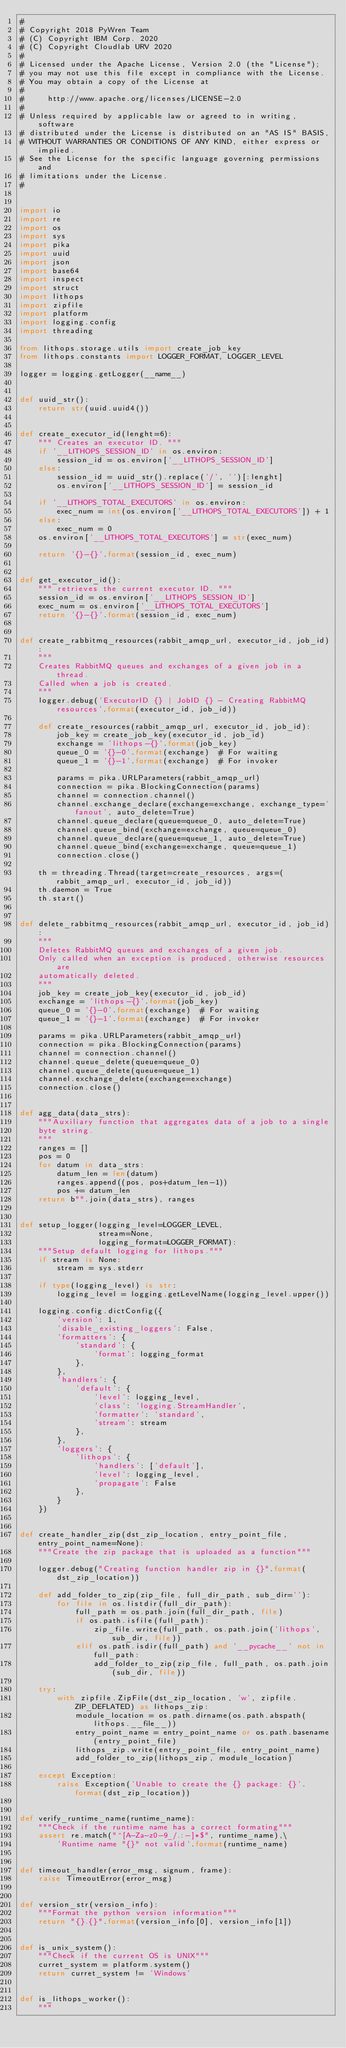<code> <loc_0><loc_0><loc_500><loc_500><_Python_>#
# Copyright 2018 PyWren Team
# (C) Copyright IBM Corp. 2020
# (C) Copyright Cloudlab URV 2020
#
# Licensed under the Apache License, Version 2.0 (the "License");
# you may not use this file except in compliance with the License.
# You may obtain a copy of the License at
#
#     http://www.apache.org/licenses/LICENSE-2.0
#
# Unless required by applicable law or agreed to in writing, software
# distributed under the License is distributed on an "AS IS" BASIS,
# WITHOUT WARRANTIES OR CONDITIONS OF ANY KIND, either express or implied.
# See the License for the specific language governing permissions and
# limitations under the License.
#


import io
import re
import os
import sys
import pika
import uuid
import json
import base64
import inspect
import struct
import lithops
import zipfile
import platform
import logging.config
import threading

from lithops.storage.utils import create_job_key
from lithops.constants import LOGGER_FORMAT, LOGGER_LEVEL

logger = logging.getLogger(__name__)


def uuid_str():
    return str(uuid.uuid4())


def create_executor_id(lenght=6):
    """ Creates an executor ID. """
    if '__LITHOPS_SESSION_ID' in os.environ:
        session_id = os.environ['__LITHOPS_SESSION_ID']
    else:
        session_id = uuid_str().replace('/', '')[:lenght]
        os.environ['__LITHOPS_SESSION_ID'] = session_id

    if '__LITHOPS_TOTAL_EXECUTORS' in os.environ:
        exec_num = int(os.environ['__LITHOPS_TOTAL_EXECUTORS']) + 1
    else:
        exec_num = 0
    os.environ['__LITHOPS_TOTAL_EXECUTORS'] = str(exec_num)

    return '{}-{}'.format(session_id, exec_num)


def get_executor_id():
    """ retrieves the current executor ID. """
    session_id = os.environ['__LITHOPS_SESSION_ID']
    exec_num = os.environ['__LITHOPS_TOTAL_EXECUTORS']
    return '{}-{}'.format(session_id, exec_num)


def create_rabbitmq_resources(rabbit_amqp_url, executor_id, job_id):
    """
    Creates RabbitMQ queues and exchanges of a given job in a thread.
    Called when a job is created.
    """
    logger.debug('ExecutorID {} | JobID {} - Creating RabbitMQ resources'.format(executor_id, job_id))

    def create_resources(rabbit_amqp_url, executor_id, job_id):
        job_key = create_job_key(executor_id, job_id)
        exchange = 'lithops-{}'.format(job_key)
        queue_0 = '{}-0'.format(exchange)  # For waiting
        queue_1 = '{}-1'.format(exchange)  # For invoker

        params = pika.URLParameters(rabbit_amqp_url)
        connection = pika.BlockingConnection(params)
        channel = connection.channel()
        channel.exchange_declare(exchange=exchange, exchange_type='fanout', auto_delete=True)
        channel.queue_declare(queue=queue_0, auto_delete=True)
        channel.queue_bind(exchange=exchange, queue=queue_0)
        channel.queue_declare(queue=queue_1, auto_delete=True)
        channel.queue_bind(exchange=exchange, queue=queue_1)
        connection.close()

    th = threading.Thread(target=create_resources, args=(rabbit_amqp_url, executor_id, job_id))
    th.daemon = True
    th.start()


def delete_rabbitmq_resources(rabbit_amqp_url, executor_id, job_id):
    """
    Deletes RabbitMQ queues and exchanges of a given job.
    Only called when an exception is produced, otherwise resources are
    automatically deleted.
    """
    job_key = create_job_key(executor_id, job_id)
    exchange = 'lithops-{}'.format(job_key)
    queue_0 = '{}-0'.format(exchange)  # For waiting
    queue_1 = '{}-1'.format(exchange)  # For invoker

    params = pika.URLParameters(rabbit_amqp_url)
    connection = pika.BlockingConnection(params)
    channel = connection.channel()
    channel.queue_delete(queue=queue_0)
    channel.queue_delete(queue=queue_1)
    channel.exchange_delete(exchange=exchange)
    connection.close()


def agg_data(data_strs):
    """Auxiliary function that aggregates data of a job to a single
    byte string.
    """
    ranges = []
    pos = 0
    for datum in data_strs:
        datum_len = len(datum)
        ranges.append((pos, pos+datum_len-1))
        pos += datum_len
    return b"".join(data_strs), ranges


def setup_logger(logging_level=LOGGER_LEVEL,
                 stream=None,
                 logging_format=LOGGER_FORMAT):
    """Setup default logging for lithops."""
    if stream is None:
        stream = sys.stderr

    if type(logging_level) is str:
        logging_level = logging.getLevelName(logging_level.upper())

    logging.config.dictConfig({
        'version': 1,
        'disable_existing_loggers': False,
        'formatters': {
            'standard': {
                'format': logging_format
            },
        },
        'handlers': {
            'default': {
                'level': logging_level,
                'class': 'logging.StreamHandler',
                'formatter': 'standard',
                'stream': stream
            },
        },
        'loggers': {
            'lithops': {
                'handlers': ['default'],
                'level': logging_level,
                'propagate': False
            },
        }
    })


def create_handler_zip(dst_zip_location, entry_point_file, entry_point_name=None):
    """Create the zip package that is uploaded as a function"""

    logger.debug("Creating function handler zip in {}".format(dst_zip_location))

    def add_folder_to_zip(zip_file, full_dir_path, sub_dir=''):
        for file in os.listdir(full_dir_path):
            full_path = os.path.join(full_dir_path, file)
            if os.path.isfile(full_path):
                zip_file.write(full_path, os.path.join('lithops', sub_dir, file))
            elif os.path.isdir(full_path) and '__pycache__' not in full_path:
                add_folder_to_zip(zip_file, full_path, os.path.join(sub_dir, file))

    try:
        with zipfile.ZipFile(dst_zip_location, 'w', zipfile.ZIP_DEFLATED) as lithops_zip:
            module_location = os.path.dirname(os.path.abspath(lithops.__file__))
            entry_point_name = entry_point_name or os.path.basename(entry_point_file)
            lithops_zip.write(entry_point_file, entry_point_name)
            add_folder_to_zip(lithops_zip, module_location)

    except Exception:
        raise Exception('Unable to create the {} package: {}'.format(dst_zip_location))


def verify_runtime_name(runtime_name):
    """Check if the runtime name has a correct formating"""
    assert re.match("^[A-Za-z0-9_/.:-]*$", runtime_name),\
        'Runtime name "{}" not valid'.format(runtime_name)


def timeout_handler(error_msg, signum, frame):
    raise TimeoutError(error_msg)


def version_str(version_info):
    """Format the python version information"""
    return "{}.{}".format(version_info[0], version_info[1])


def is_unix_system():
    """Check if the current OS is UNIX"""
    curret_system = platform.system()
    return curret_system != 'Windows'


def is_lithops_worker():
    """</code> 